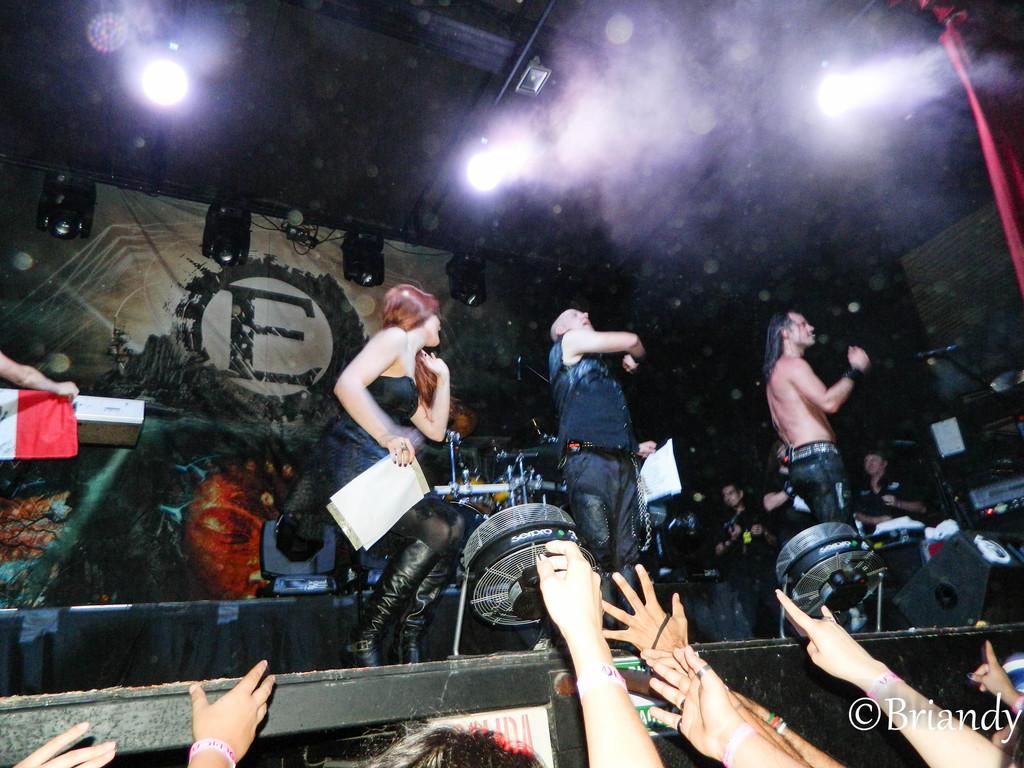Can you describe this image briefly? In this image I can see few people are standing and one person is holding papers. I can see few musical instruments on the stage. In front I can see few hands of the people. Back I can see the banner and lights. 